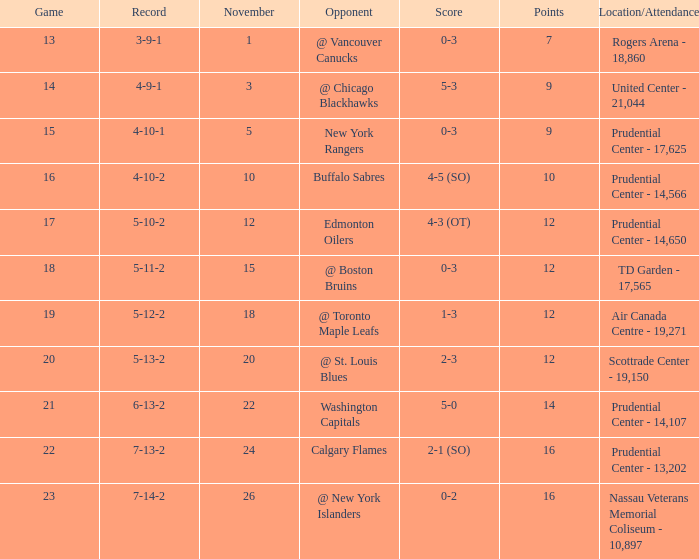Who was the opponent where the game is 14? @ Chicago Blackhawks. 